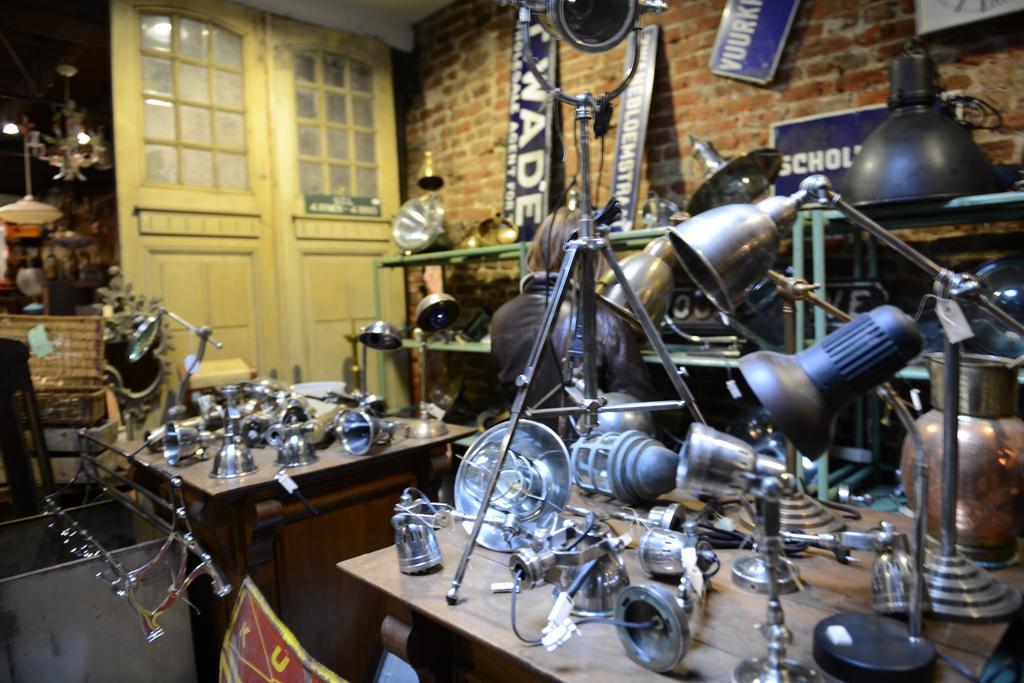Could you give a brief overview of what you see in this image? In this image at the bottom there are some tables, on the tables there are a group of lamps and some other objects. In the background there is one person who is standing and there are some cupboards, in that cupboards also there are some lights and lamps. On the left side there is a door, in the background there is a wall and some boards. On the boards there is some text, on the left side there are some lights, boxes and some other objects. At the bottom there is one container and some objects. 